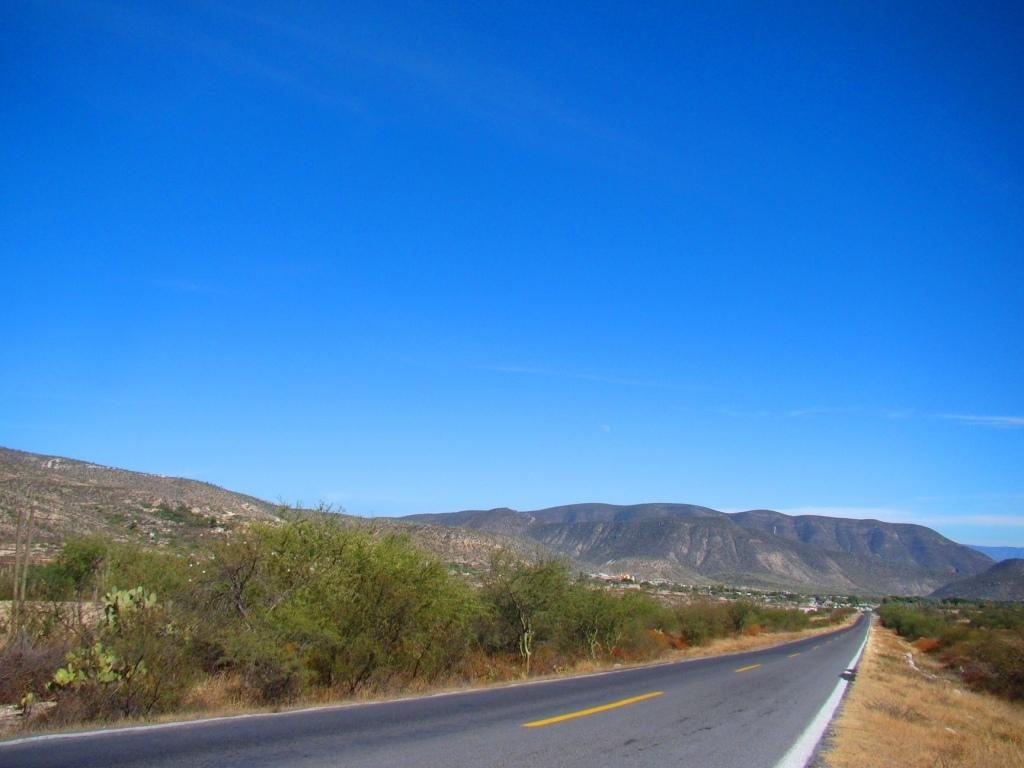What is the main feature in the middle of the image? There is a road in the middle of the image. What can be seen beside the road? There are trees beside the road. What is visible in the background of the image? There are hills and clouds visible in the background of the image. What type of notebook is being used by the trees in the image? There is no notebook present in the image, as it features a road, trees, hills, and clouds. 